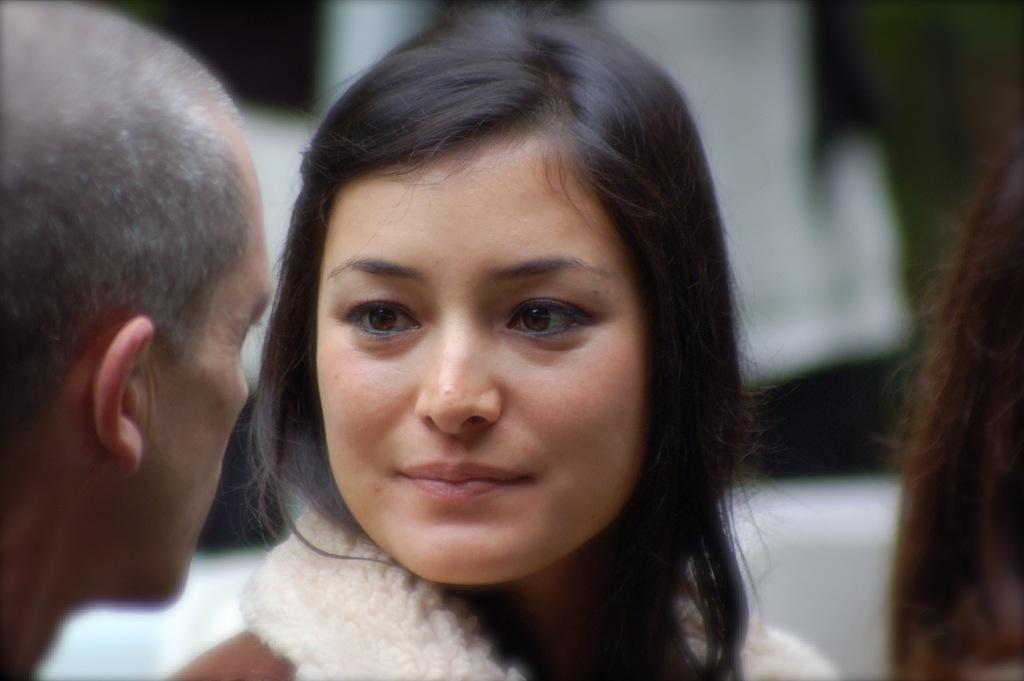How many people are in the image? There are two persons in the image. What are the two persons doing in the image? The two persons are looking at each other. Can you describe the background of the image? The background of the image is blurred. Reasoning: Let' Let's think step by step in order to produce the conversation. We start by identifying the number of people in the image, which is two. Then, we describe their actions, noting that they are looking at each other. Finally, we mention the background of the image, which is blurred. Each question is designed to elicit a specific detail about the image that is known from the provided facts. Absurd Question/Answer: What type of silk fabric is draped over the camp in the image? There is no silk fabric or camp present in the image. What type of pancake is being flipped by one of the persons in the image? There is no pancake or flipping action present in the image. 